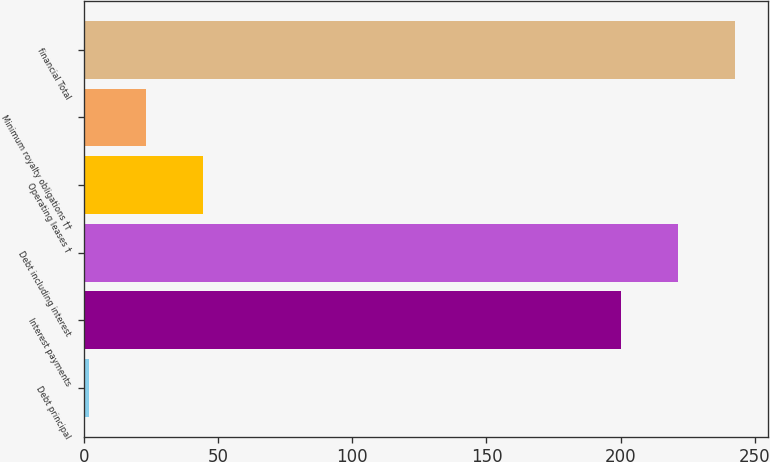Convert chart to OTSL. <chart><loc_0><loc_0><loc_500><loc_500><bar_chart><fcel>Debt principal<fcel>Interest payments<fcel>Debt including interest<fcel>Operating leases †<fcel>Minimum royalty obligations ††<fcel>financial Total<nl><fcel>2<fcel>200<fcel>221.3<fcel>44.6<fcel>23.3<fcel>242.6<nl></chart> 